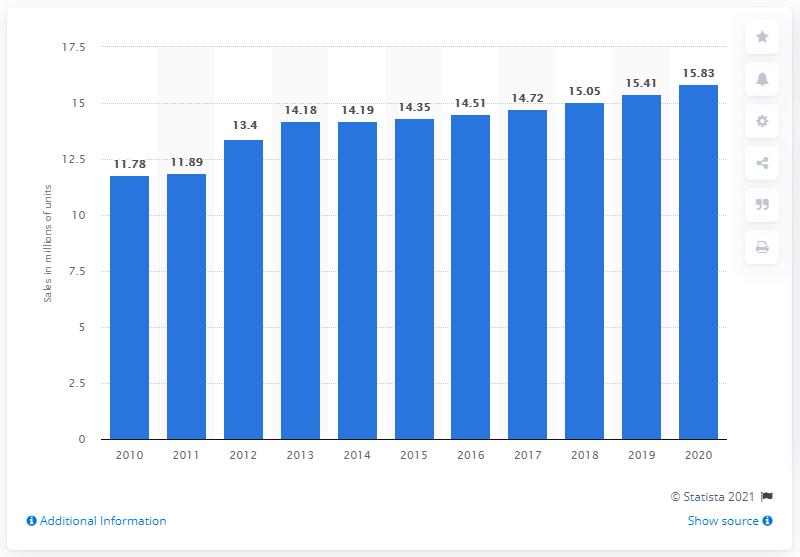Identify some key points in this picture. In 2015, a total of 14,350 electric bicycles were sold to customers in China. 